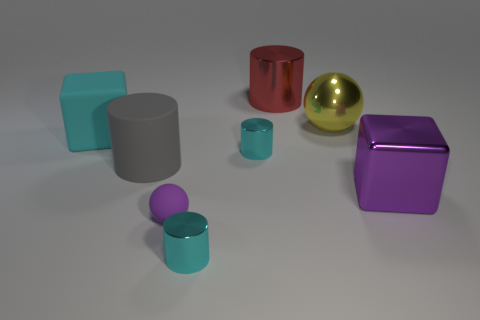Add 1 big purple metallic things. How many objects exist? 9 Subtract all red shiny cylinders. How many cylinders are left? 3 Subtract all spheres. How many objects are left? 6 Subtract 1 cubes. How many cubes are left? 1 Add 7 tiny yellow things. How many tiny yellow things exist? 7 Subtract all yellow spheres. How many spheres are left? 1 Subtract 1 cyan cubes. How many objects are left? 7 Subtract all purple spheres. Subtract all gray cubes. How many spheres are left? 1 Subtract all blue cubes. How many purple spheres are left? 1 Subtract all small purple objects. Subtract all small cyan rubber cylinders. How many objects are left? 7 